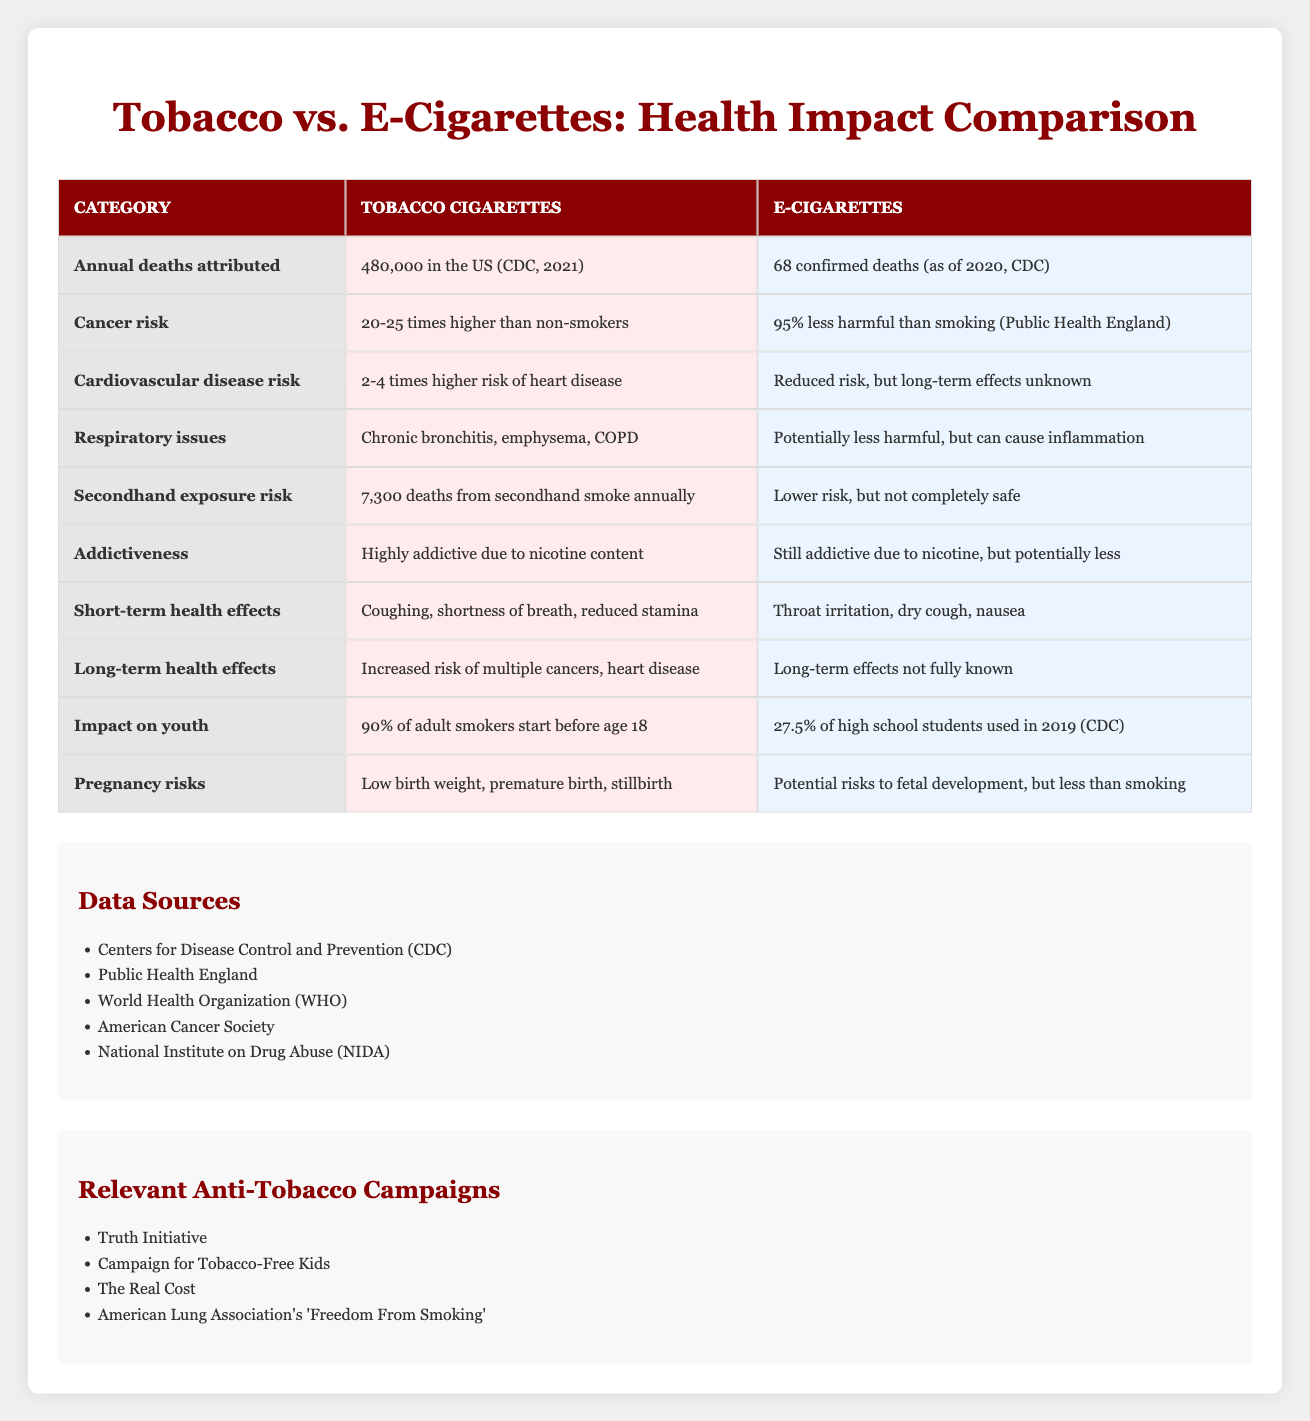What is the number of annual deaths attributed to tobacco cigarettes in the US according to the table? The table states that the annual deaths attributed to tobacco cigarettes are "480,000 in the US (CDC, 2021)."
Answer: 480,000 How many confirmed deaths are attributed to e-cigarettes as of 2020? The table indicates that there have been "68 confirmed deaths (as of 2020, CDC)" attributed to e-cigarettes.
Answer: 68 Is the cancer risk for tobacco cigarettes higher than that for e-cigarettes? The table shows that the cancer risk for tobacco cigarettes is "20-25 times higher than non-smokers," while e-cigarettes are noted as "95% less harmful than smoking," indicating that tobacco has a higher risk.
Answer: Yes What is the difference in the respiratory issues between tobacco cigarettes and e-cigarettes? For tobacco cigarettes, the table lists "Chronic bronchitis, emphysema, COPD," while e-cigarettes are described as "Potentially less harmful, but can cause inflammation," demonstrating a significant difference in severity and type of respiratory issues.
Answer: Chronic conditions for tobacco vs. inflammation for e-cigarettes What percentage of high school students used e-cigarettes in 2019 according to the table? The table states that "27.5% of high school students used in 2019 (CDC)," providing the specific percentage.
Answer: 27.5% How does the impact of secondhand exposure from tobacco compare to that of e-cigarettes? The table lists "7,300 deaths from secondhand smoke annually" for tobacco, whereas e-cigarettes have a "lower risk, but not completely safe" designation, indicating that tobacco's secondhand effects are far more severe.
Answer: Tobacco has a higher risk of secondhand exposure What kind of short-term health effects are reported for tobacco cigarettes compared to e-cigarettes? The table notes that tobacco cigarettes lead to "Coughing, shortness of breath, reduced stamina," while e-cigarettes are associated with "Throat irritation, dry cough, nausea," showing that tobacco's effects are generally more severe.
Answer: Tobacco has harsher effects What is one potential risk to fetal development associated with e-cigarettes? According to the table, e-cigarettes carry "Potential risks to fetal development, but less than smoking," which answers the question regarding fetal risks.
Answer: Potential fetal risks less than smoking What can be inferred about the addictiveness of e-cigarettes compared to tobacco cigarettes? The table indicates that tobacco is "Highly addictive due to nicotine content," while for e-cigarettes, it states they are "Still addictive due to nicotine, but potentially less," suggesting tobacco is more addictive.
Answer: Tobacco is more addictive 